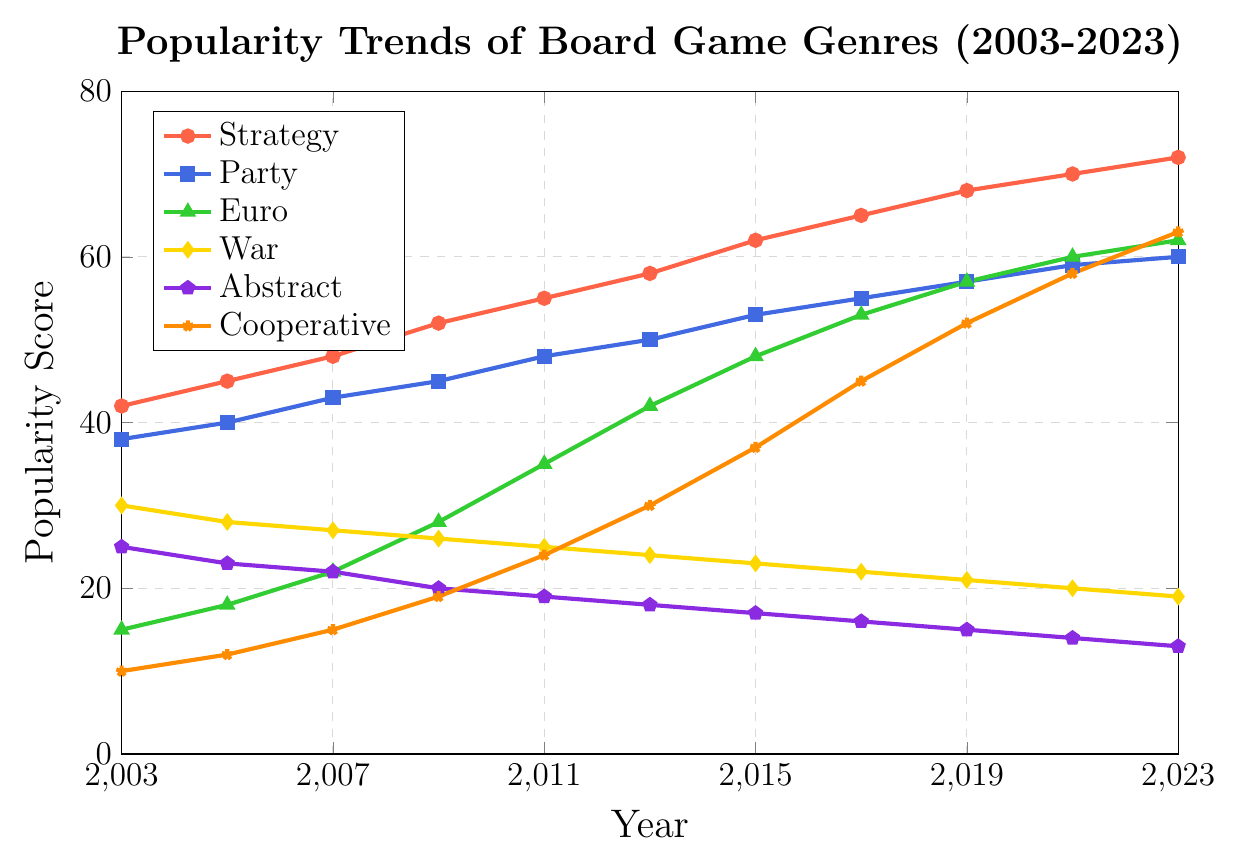Which genre has the highest popularity score in 2023? By observing the peaks in the line chart for the year 2023, the Strategy genre reaches the highest score at 72.
Answer: Strategy How did the popularity of Cooperative games change from 2003 to 2023? The Cooperative genre starts at 10 in 2003 and increases steadily to 63 by 2023. Subtracting the initial score from the final score, (63 - 10), the popularity increased by 53 points.
Answer: Increased by 53 points Which genre shows a continuous decline in popularity over the 20 years? By tracing the line trends downward consistently, both the War and Abstract genres show a continuous decline. War starts at 30 and ends at 19, Abstract starts at 25 and ends at 13.
Answer: War and Abstract For which years are the popularity scores of the Party and War genres equivalent? Observing the intersection of the lines for Party and War genres, they do not intersect at any point, indicating no years with equivalent scores.
Answer: None What is the average popularity score of the Euro genre over the 20 years? To find the average, sum all points for Euro from 2003 to 2023 and divide by the number of years: (15+18+22+28+35+42+48+53+57+60+62) = 440. Dividing by 11 years, 440 / 11 = 40.
Answer: 40 Which genre shows the most significant popularity increase between two consecutive points? By examining the steepest slopes between points, Cooperative from 2007 (15) to 2009 (19) shows an increase of 4 points, which is less than other segments, while increases for Strategy, Euro, etc. are less prominent compared to start-end gaps, signifying Cooperative's multiple incremental jumps.
Answer: Cooperative What is the total increase in popularity for the Euro genre from 2003 to 2023? The Euro genre starts at 15 in 2003 and climbs to 62 by 2023. The total increase is calculated as 62 - 15 = 47.
Answer: 47 In which year did the Abstract genre first drop below 20? Tracking the downward slope, Abstract falls from 20 to below 19 between 2009 and 2011, noticing it first drops below 20 in 2009 with 20 points then in 2011 drops at 18.
Answer: 2009 Which two genres have popularity scores that are closest to each other in 2023? By observing the endpoints for 2023, Party scores 60, and Euro scores 62. The difference is minimal at 62-60 = 2.
Answer: Party and Euro 